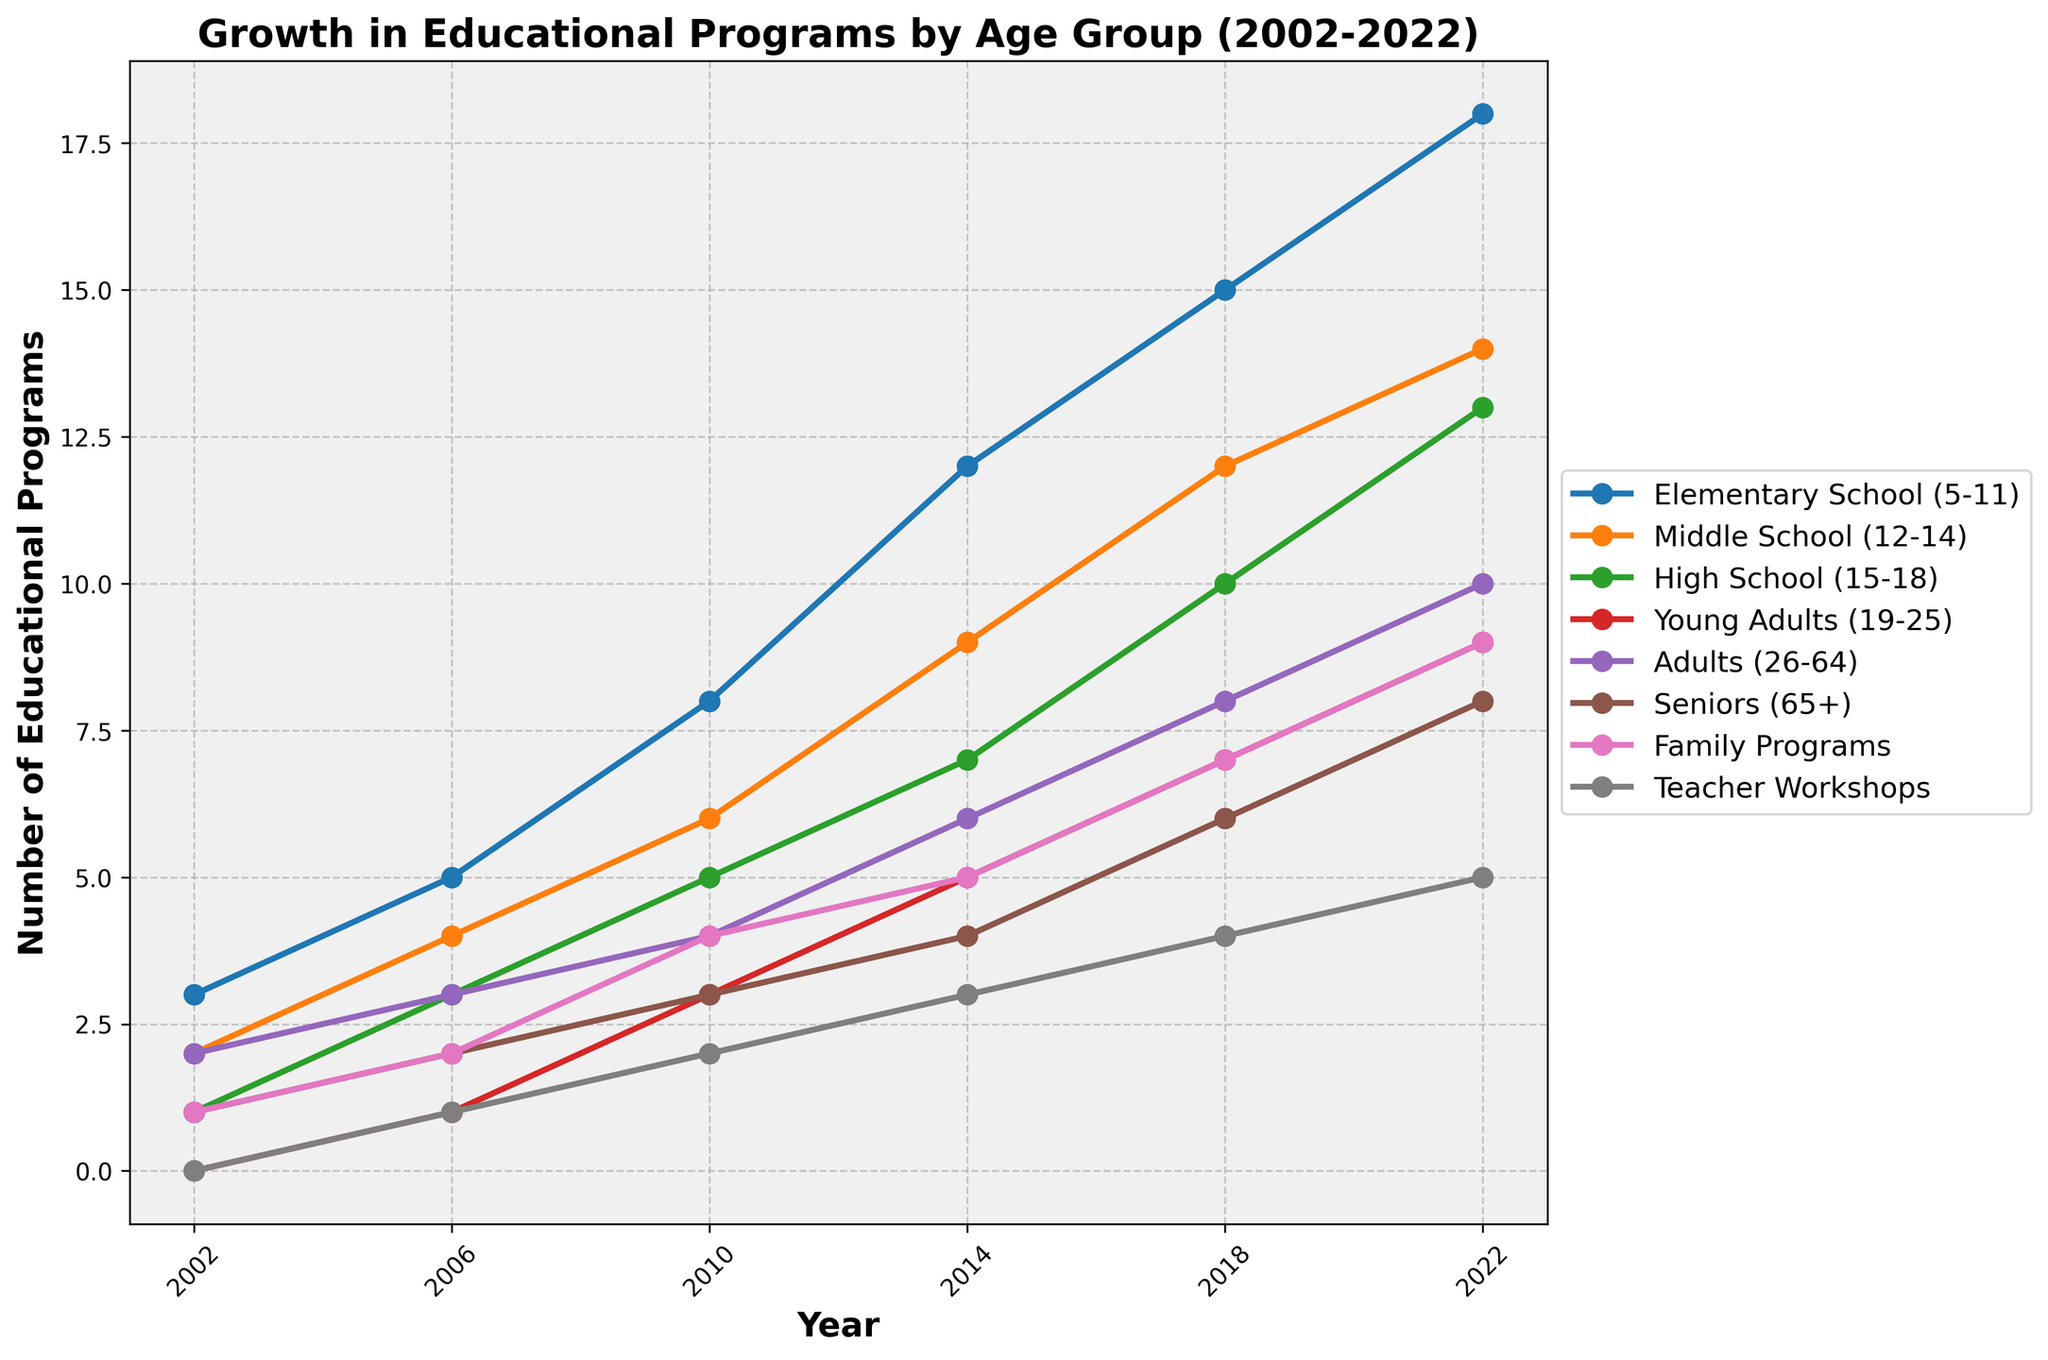Which age group had the highest number of educational programs in 2022? To find the answer, look at the data points for 2022 for each age group and compare them. The highest number is 18 for the Elementary School group.
Answer: Elementary School (5-11) How many educational programs were offered to Young Adults (19-25) in 2010 and what was the increase from 2002 to 2010? First, find the number of programs in 2010 (which is 3) and then subtract the number from 2002 (which is 0). The increase is 3 - 0 = 3.
Answer: 3; 3 Which two age groups had an equal number of educational programs in 2010? Look at the data for 2010 and find the age groups with equal values. Both Seniors (65+) and Teacher Workshops had 3 programs in 2010.
Answer: Seniors (65+), Teacher Workshops What is the difference between the number of programs for Elementary School children and Adults in 2022? Find the values for Elementary School (18 programs) and Adults (10 programs) in 2022, then subtract the smaller number from the larger: 18 - 10 = 8.
Answer: 8 Compare the growth rate of educational programs for Middle School (12-14) and High School (15-18) from 2002 to 2022. Which group had a higher growth rate? Calculate the growth for each group: For Middle School, it goes from 2 to 14, an increase of 12. For High School, it goes from 1 to 13, also an increase of 12. Both groups have the same growth rate.
Answer: Same growth rate Which group showed the most considerable overall increase in the number of educational programs from 2002 to 2022? Check the difference in values for each group between 2002 and 2022. The Elementary School (5-11) group increased from 3 to 18, an increase of 15. This is the highest overall increase.
Answer: Elementary School (5-11) How many total programs were offered to Seniors (65+) across all years listed? Add the number of programs offered to Seniors in each year: 1 (2002) + 2 (2006) + 3 (2010) + 4 (2014) + 6 (2018) + 8 (2022) = 24
Answer: 24 In which year did Family Programs see the most significant increase compared to the previous year? Evaluate the yearly increase: from 2002 to 2006 (1 to 2, +1), from 2006 to 2010 (2 to 4, +2), from 2010 to 2014 (4 to 5, +1), from 2014 to 2018 (5 to 7, +2), from 2018 to 2022 (7 to 9, +2). The most significant increase is from 2006 to 2010 (+2).
Answer: 2010 How many programs in total were offered across all age groups in 2018? Sum the values for each group in 2018: 15 (Elementary) + 12 (Middle School) + 10 (High School) + 7 (Young Adults) + 8 (Adults) + 6 (Seniors) + 7 (Family) + 4 (Teachers) = 69.
Answer: 69 What is the average number of educational programs offered to Adults (26-64) over the years listed? Sum the numbers of Adult programs: 2 + 3 + 4 + 6 + 8 + 10 = 33. Divide by the number of years (6): 33/6 = 5.5
Answer: 5.5 